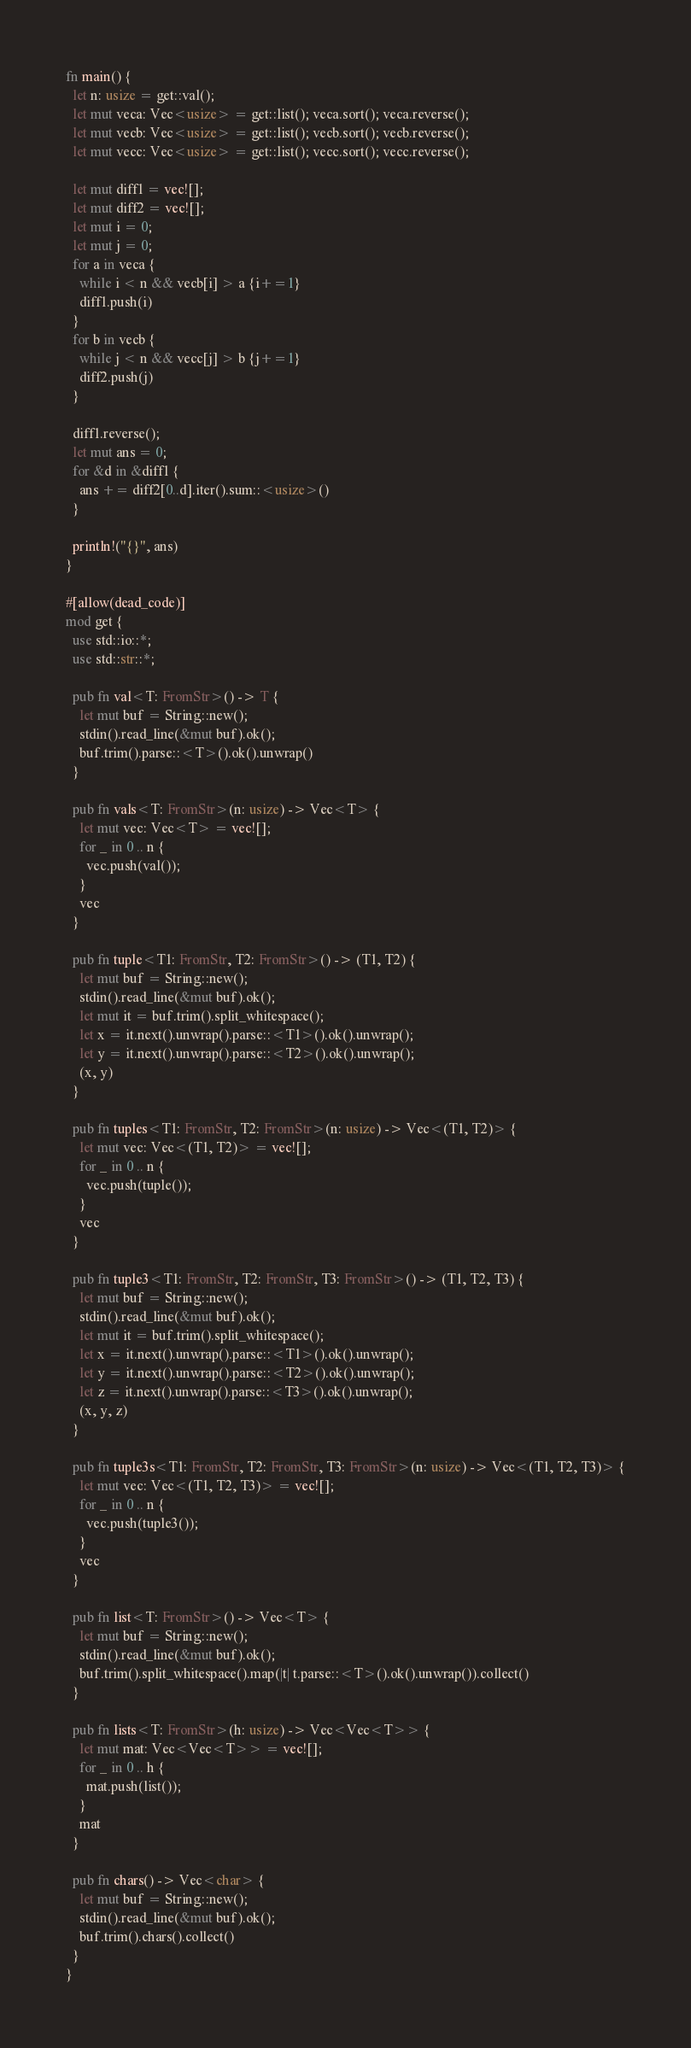<code> <loc_0><loc_0><loc_500><loc_500><_Rust_>fn main() {
  let n: usize = get::val();
  let mut veca: Vec<usize> = get::list(); veca.sort(); veca.reverse();
  let mut vecb: Vec<usize> = get::list(); vecb.sort(); vecb.reverse();
  let mut vecc: Vec<usize> = get::list(); vecc.sort(); vecc.reverse();

  let mut diff1 = vec![];
  let mut diff2 = vec![];
  let mut i = 0;
  let mut j = 0;
  for a in veca {
    while i < n && vecb[i] > a {i+=1}
    diff1.push(i)
  }
  for b in vecb {
    while j < n && vecc[j] > b {j+=1}
    diff2.push(j)
  }

  diff1.reverse();
  let mut ans = 0;
  for &d in &diff1 {
    ans += diff2[0..d].iter().sum::<usize>()
  }

  println!("{}", ans)
}

#[allow(dead_code)]
mod get {
  use std::io::*;
  use std::str::*;

  pub fn val<T: FromStr>() -> T {
    let mut buf = String::new();
    stdin().read_line(&mut buf).ok();
    buf.trim().parse::<T>().ok().unwrap()
  }

  pub fn vals<T: FromStr>(n: usize) -> Vec<T> {
    let mut vec: Vec<T> = vec![];
    for _ in 0 .. n {
      vec.push(val());
    }
    vec
  }

  pub fn tuple<T1: FromStr, T2: FromStr>() -> (T1, T2) {
    let mut buf = String::new();
    stdin().read_line(&mut buf).ok();
    let mut it = buf.trim().split_whitespace();
    let x = it.next().unwrap().parse::<T1>().ok().unwrap();
    let y = it.next().unwrap().parse::<T2>().ok().unwrap();
    (x, y)
  }

  pub fn tuples<T1: FromStr, T2: FromStr>(n: usize) -> Vec<(T1, T2)> {
    let mut vec: Vec<(T1, T2)> = vec![];
    for _ in 0 .. n {
      vec.push(tuple());
    }
    vec
  }

  pub fn tuple3<T1: FromStr, T2: FromStr, T3: FromStr>() -> (T1, T2, T3) {
    let mut buf = String::new();
    stdin().read_line(&mut buf).ok();
    let mut it = buf.trim().split_whitespace();
    let x = it.next().unwrap().parse::<T1>().ok().unwrap();
    let y = it.next().unwrap().parse::<T2>().ok().unwrap();
    let z = it.next().unwrap().parse::<T3>().ok().unwrap();
    (x, y, z)
  }

  pub fn tuple3s<T1: FromStr, T2: FromStr, T3: FromStr>(n: usize) -> Vec<(T1, T2, T3)> {
    let mut vec: Vec<(T1, T2, T3)> = vec![];
    for _ in 0 .. n {
      vec.push(tuple3());
    }
    vec
  }

  pub fn list<T: FromStr>() -> Vec<T> {
    let mut buf = String::new();
    stdin().read_line(&mut buf).ok();
    buf.trim().split_whitespace().map(|t| t.parse::<T>().ok().unwrap()).collect()
  }

  pub fn lists<T: FromStr>(h: usize) -> Vec<Vec<T>> {
    let mut mat: Vec<Vec<T>> = vec![];
    for _ in 0 .. h {
      mat.push(list());
    }
    mat
  }

  pub fn chars() -> Vec<char> {
    let mut buf = String::new();
    stdin().read_line(&mut buf).ok();
    buf.trim().chars().collect()
  }
}
</code> 